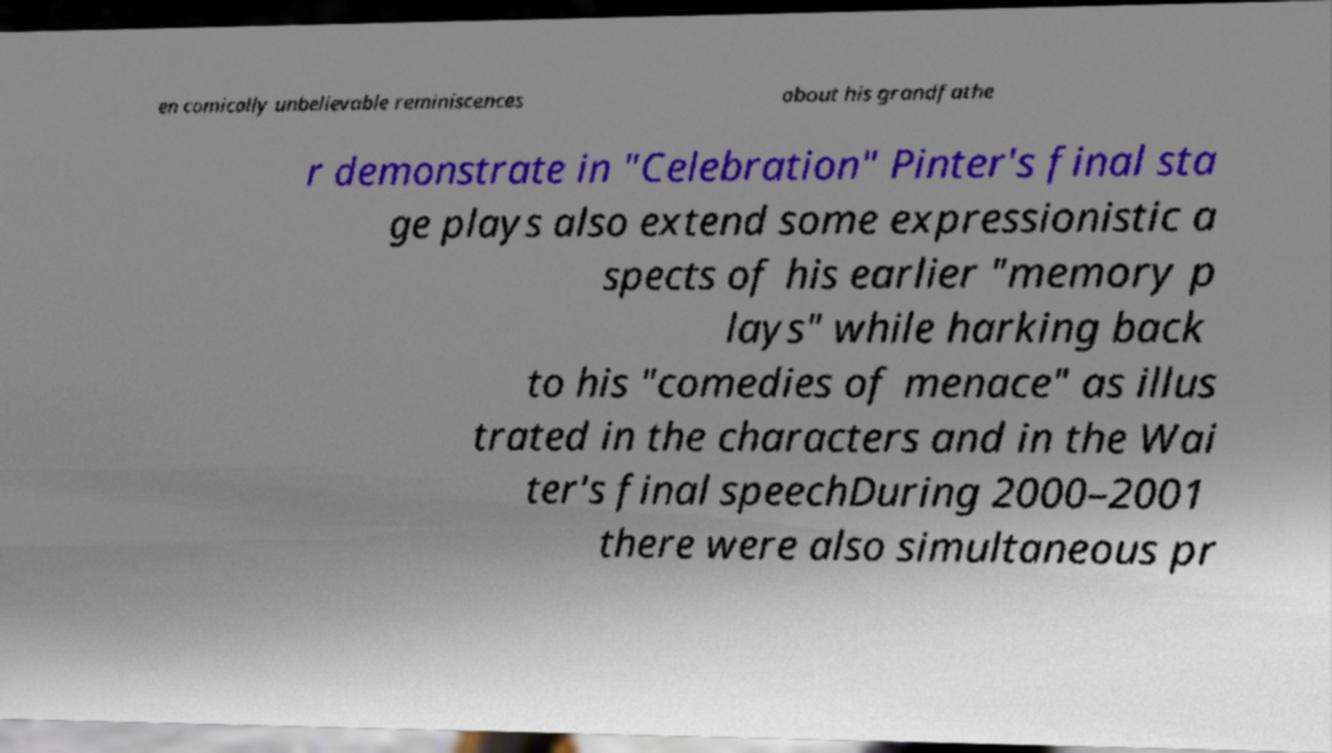Could you assist in decoding the text presented in this image and type it out clearly? en comically unbelievable reminiscences about his grandfathe r demonstrate in "Celebration" Pinter's final sta ge plays also extend some expressionistic a spects of his earlier "memory p lays" while harking back to his "comedies of menace" as illus trated in the characters and in the Wai ter's final speechDuring 2000–2001 there were also simultaneous pr 